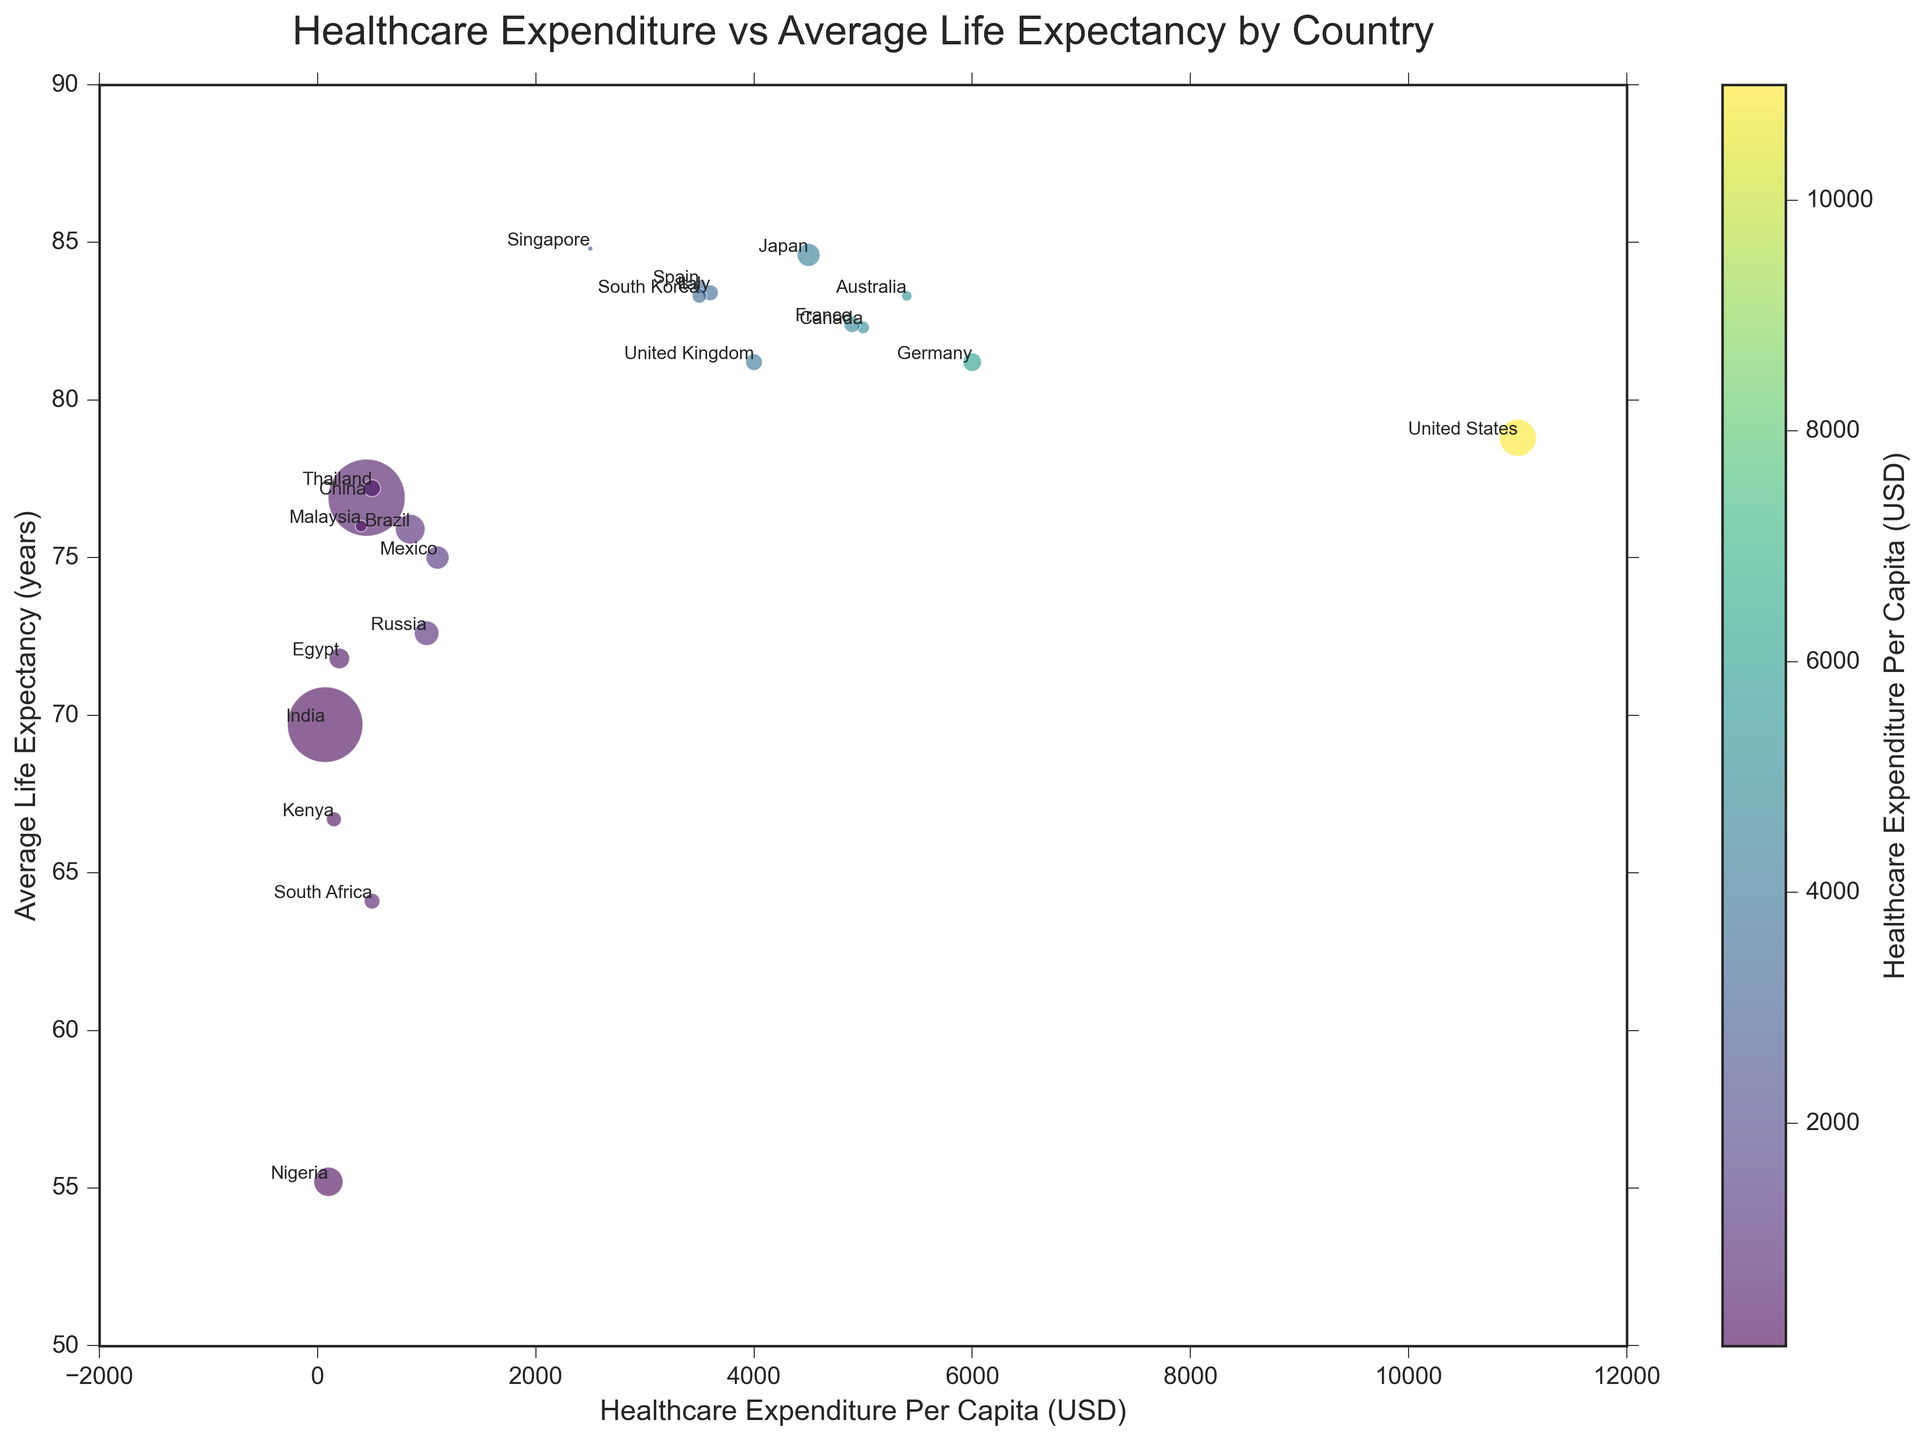Which country has the highest healthcare expenditure per capita? By checking the country with the largest value on the x-axis (Healthcare Expenditure Per Capita), we see that the United States has the highest healthcare expenditure per capita.
Answer: United States What is the average life expectancy for countries with healthcare expenditure per capita greater than $5000? Countries with healthcare expenditure per capita greater than $5000 are the United States, Canada, Germany, and Australia. Their average life expectancies are 78.8, 82.3, 81.2, and 83.3 years respectively. The average is (78.8 + 82.3 + 81.2 + 83.3) / 4 = 81.4.
Answer: 81.4 years Which country has the lowest average life expectancy and what is its healthcare expenditure per capita? By identifying the country with the smallest value on the y-axis (Average Life Expectancy), we see that Nigeria has the lowest average life expectancy. Its healthcare expenditure per capita stands at $100.
Answer: Nigeria, $100 How does China's healthcare expenditure per capita compare to South Korea's? By comparing the x-axis values for China and South Korea, we see China's healthcare expenditure per capita is $450, while South Korea's is $3500. Thus, South Korea spends significantly more on healthcare per capita than China.
Answer: South Korea has higher expenditure What is the combined average life expectancy of countries with healthcare expenditure per capita below $1000? Countries with healthcare expenditure per capita below $1000 are China, India, Brazil, Russia, Mexico, South Africa, Egypt, Nigeria, Kenya, and Malaysia. Their average life expectancies are 76.9, 69.7, 75.9, 72.6, 75.0, 64.1, 71.8, 55.2, 66.7, and 76.0 years respectively. The combined average is (76.9 + 69.7 + 75.9 + 72.6 + 75.0 + 64.1 + 71.8 + 55.2 + 66.7 + 76.0) / 10 = 70.39.
Answer: 70.39 years 